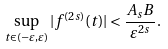Convert formula to latex. <formula><loc_0><loc_0><loc_500><loc_500>\sup _ { t \in ( - \varepsilon , \varepsilon ) } | f ^ { ( 2 s ) } ( t ) | < \frac { A _ { s } B } { \varepsilon ^ { 2 s } } .</formula> 